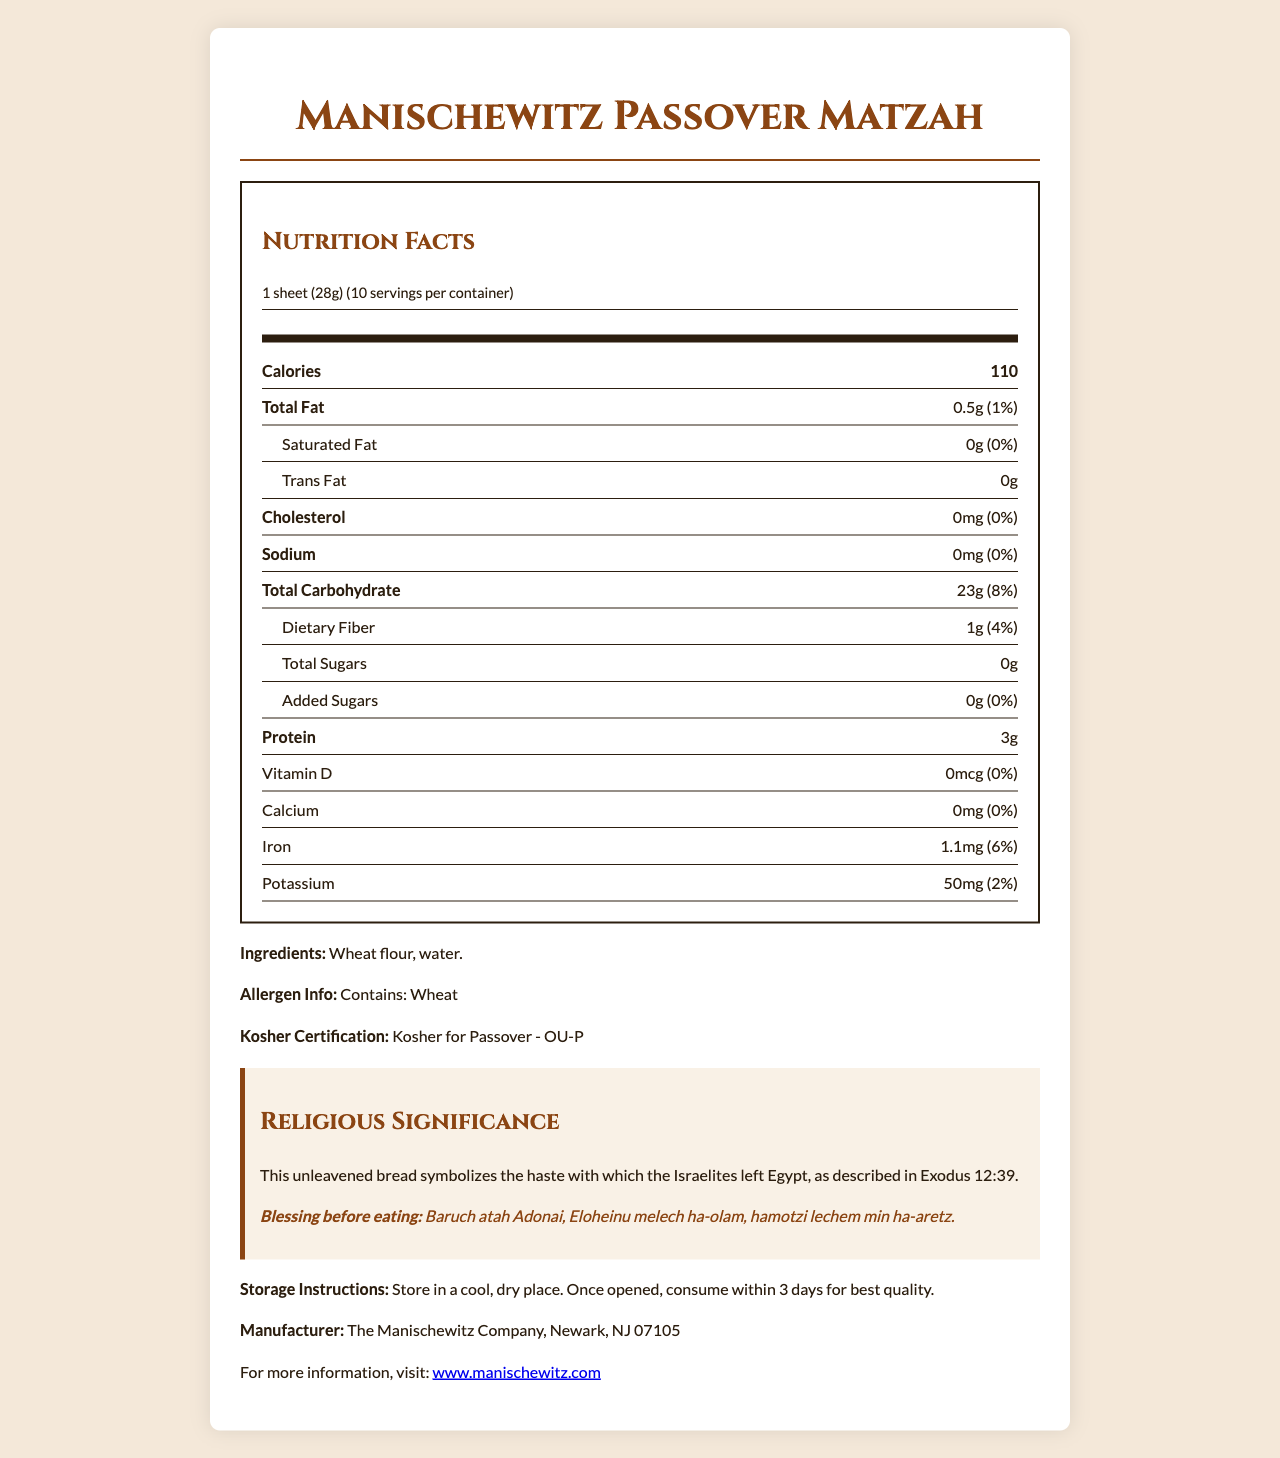what is the serving size for the Manischewitz Passover Matzah? The serving size is specified as "1 sheet (28g)".
Answer: 1 sheet (28g) how many servings are there per container? The document lists "10" as the number of servings per container.
Answer: 10 how many calories are in one serving? The document states that there are 110 calories per serving.
Answer: 110 what is the total fat content per serving? The total fat content per serving is given as "0.5g".
Answer: 0.5g how much iron does each serving provide? The iron content per serving is listed as "1.1mg".
Answer: 1.1mg how much dietary fiber does one serving have? The dietary fiber content per serving is listed as “1g”.
Answer: 1g what is the blessing before eating the matzah? The document quotes the blessing in the religious significance section.
Answer: Baruch atah Adonai, Eloheinu melech ha-olam, hamotzi lechem min ha-aretz. how should the matzah be stored after opening the package? The storage instructions are specified in the document.
Answer: Store in a cool, dry place. Once opened, consume within 3 days for best quality. who is the manufacturer of the Manischewitz Passover Matzah? The manufacturer info provides this detail.
Answer: The Manischewitz Company, Newark, NJ 07105 what is the potassium content per serving? A. 20mg B. 30mg C. 50mg D. 70mg The potassium content per serving is specified as "50mg".
Answer: C. 50mg which nutrient has a daily value of 0% in this product? A. Protein B. Sodium C. Carbohydrates D. Fiber The daily value of sodium is listed as "0%" in the document.
Answer: B. Sodium Is this product kosher for Passover? The document confirms that it is "Kosher for Passover - OU-P".
Answer: Yes does this product contain wheat? The allergen info section explicitly states that the product contains wheat.
Answer: Yes what ingredients are used in this matzah? The ingredients listed are "Wheat flour, water."
Answer: Wheat flour, water. provide a summary of the document. The document comprehensively outlines the nutrition and background information about Manischewitz Passover Matzah, ensuring consumers are well-informed.
Answer: The document provides detailed nutrition facts for Manischewitz Passover Matzah, including serving size, calorie content, and nutrient information. It also includes allergen information, kosher certification, religious significance, a blessing, storage instructions, manufacturer details, and a website for more information. does this product provide any vitamin D? The document states that the vitamin D content is "0mcg," which means it provides none.
Answer: No what is the purpose of this matzah according to the document? The religious significance section explains this purpose.
Answer: It symbolizes the haste with which the Israelites left Egypt, as described in Exodus 12:39. Is there any cholesterol in this product? The cholesterol content is listed as "0mg," indicating that there is none.
Answer: No what is the total carbohydrate content per serving? The total carbohydrate content per serving is detailed as "23g".
Answer: 23g how much cholesterol is in one serving of the Manischewitz Passover Matzah? The cholesterol amount per serving is specified as "0mg".
Answer: 0mg what is the website for more information on this product? The document provides the website address for more information.
Answer: www.manischewitz.com what is the amount of added sugars per serving? The added sugars per serving is listed as "0g".
Answer: 0g how much dietary fiber is in a serving, compared to the daily value percentage? The dietary fiber in one serving is 1g, and it represents 4% of the daily value.
Answer: 1g (4%) what is the percentage of the daily value for iron in a serving of this product? The document states that the percentage of the daily value for iron is 6%.
Answer: 6% does the nutritional information include any vitamin C content? The document does not provide any details regarding vitamin C content.
Answer: Not enough information 